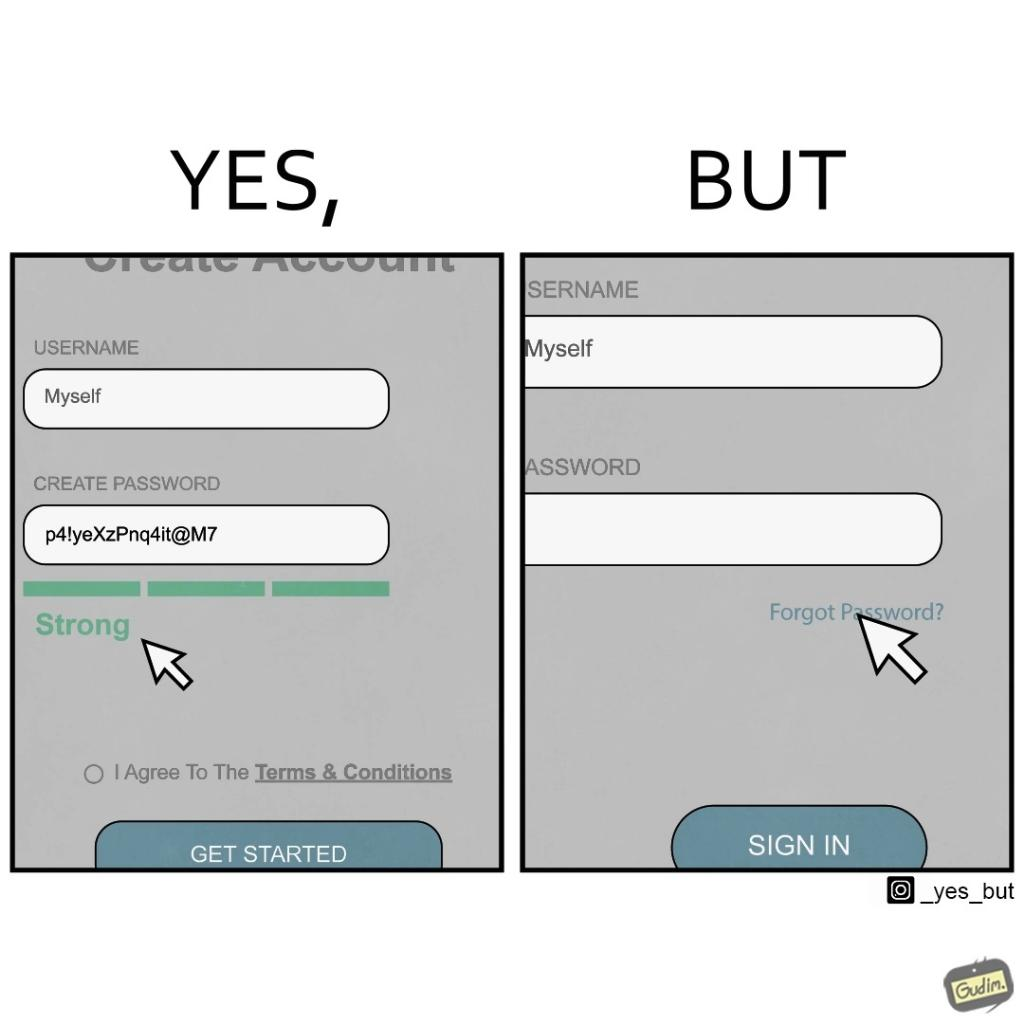Describe the contrast between the left and right parts of this image. In the left part of the image: a screenshot of an account creation page of some site with login details filled in such as username and create password and password strength checker showing password as "strong" In the right part of the image: a screenshot of a login page of some site with username filled in and the user about to click on "Forget Password" link as the pointer is over the link 